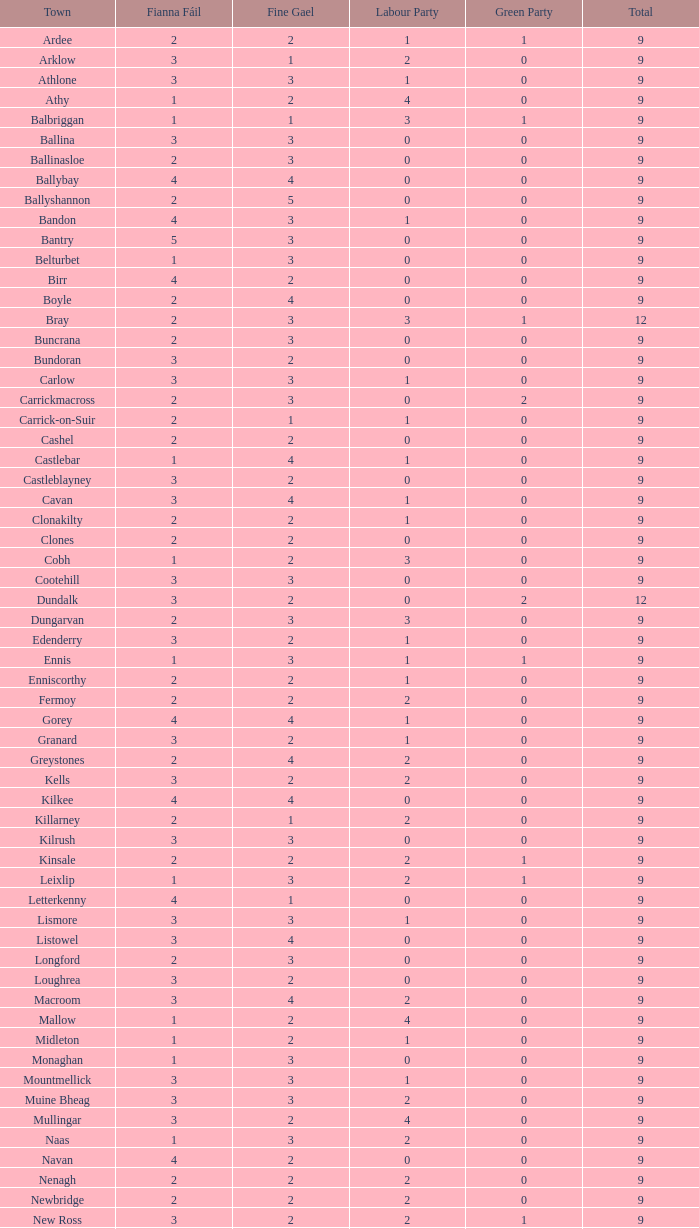How many are in the Green Party with a Fine Gael of less than 4 and a Fianna Fail of less than 2 in Athy? 0.0. 